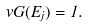<formula> <loc_0><loc_0><loc_500><loc_500>v G ( E _ { j } ) = 1 .</formula> 